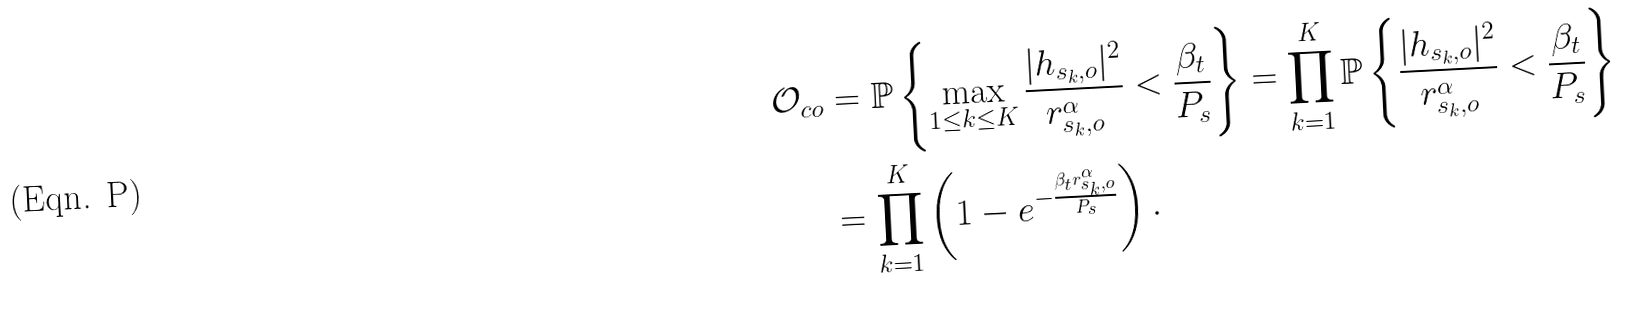Convert formula to latex. <formula><loc_0><loc_0><loc_500><loc_500>\mathcal { O } _ { c o } & = \mathbb { P } \left \{ \max _ { 1 \leq k \leq K } \frac { | h _ { s _ { k } , o } | ^ { 2 } } { r _ { s _ { k } , o } ^ { \alpha } } < \frac { \beta _ { t } } { P _ { s } } \right \} = \prod _ { k = 1 } ^ { K } \mathbb { P } \left \{ \frac { | h _ { s _ { k } , o } | ^ { 2 } } { r _ { s _ { k } , o } ^ { \alpha } } < \frac { \beta _ { t } } { P _ { s } } \right \} \\ & = \prod _ { k = 1 } ^ { K } \left ( 1 - e ^ { - \frac { \beta _ { t } r _ { s _ { k } , o } ^ { \alpha } } { P _ { s } } } \right ) .</formula> 